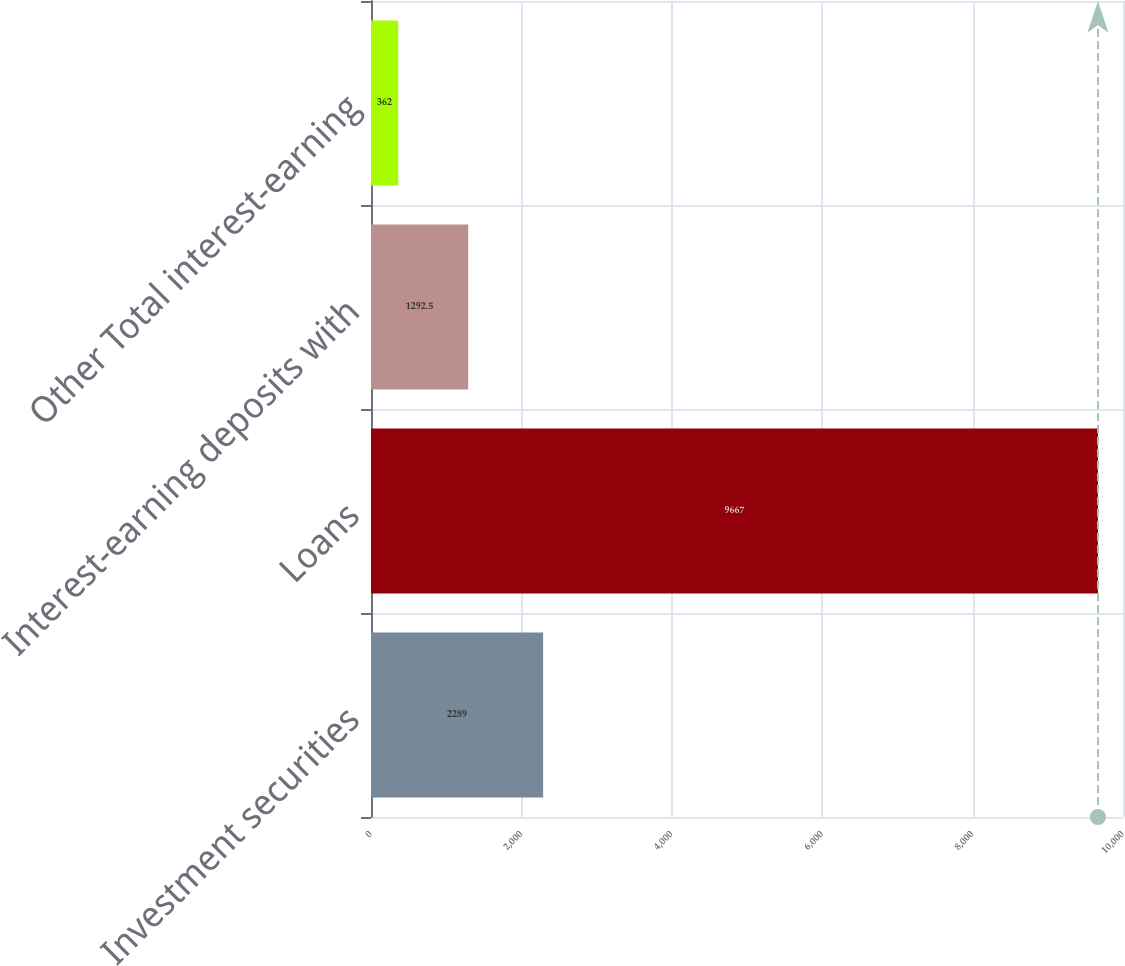<chart> <loc_0><loc_0><loc_500><loc_500><bar_chart><fcel>Investment securities<fcel>Loans<fcel>Interest-earning deposits with<fcel>Other Total interest-earning<nl><fcel>2289<fcel>9667<fcel>1292.5<fcel>362<nl></chart> 